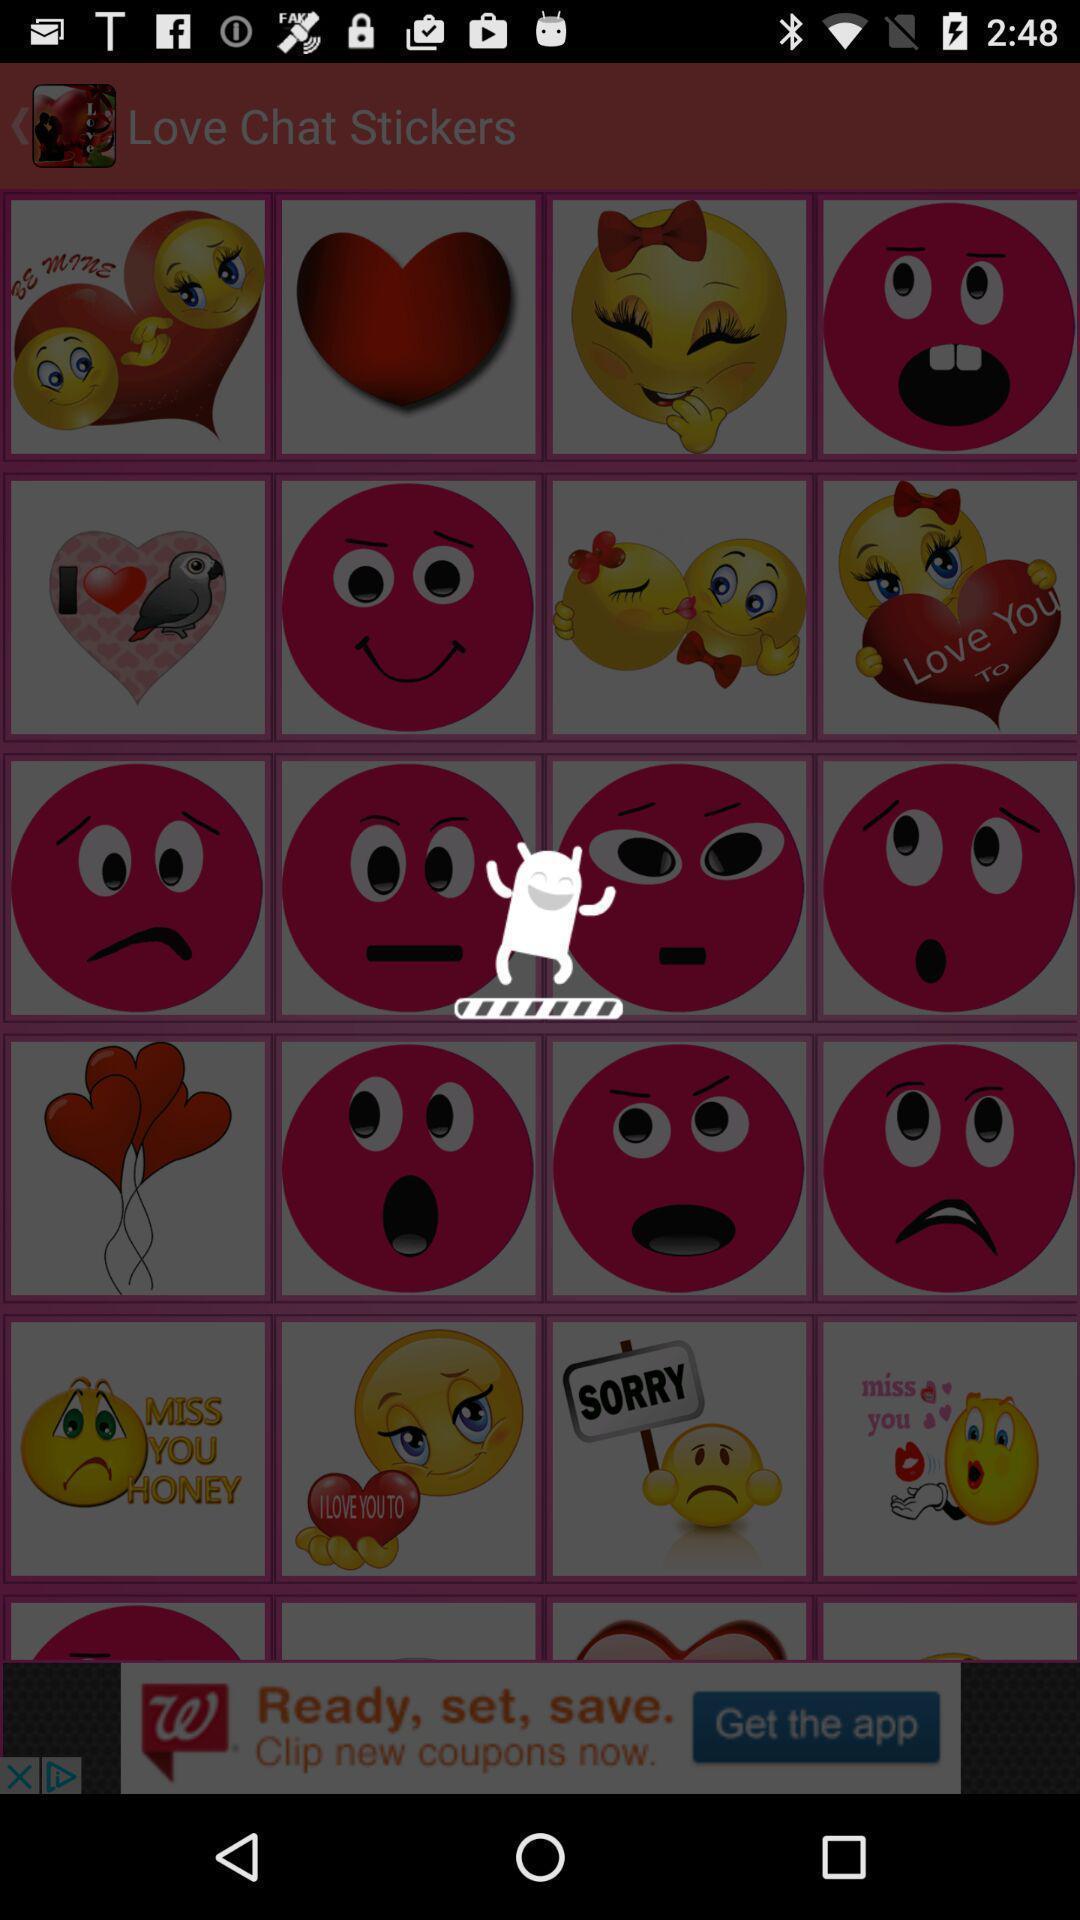Describe the key features of this screenshot. Page displaying menu of emojis. 